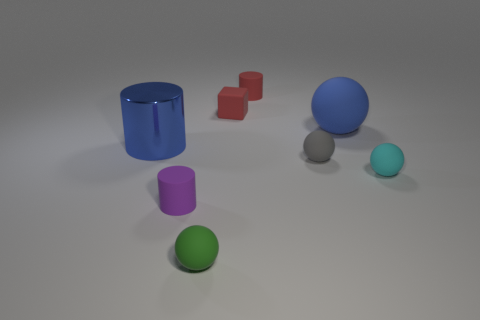What shape is the rubber thing that is both behind the small cyan ball and in front of the blue cylinder?
Ensure brevity in your answer.  Sphere. How many objects are purple cylinders or small cylinders on the left side of the small green object?
Your answer should be very brief. 1. Are the green thing and the tiny red cylinder made of the same material?
Give a very brief answer. Yes. What number of other things are there of the same shape as the cyan matte thing?
Keep it short and to the point. 3. What size is the rubber thing that is behind the large blue cylinder and in front of the rubber cube?
Provide a succinct answer. Large. How many shiny objects are either blue blocks or big blue spheres?
Your response must be concise. 0. There is a small object that is right of the gray thing; is its shape the same as the tiny rubber object that is in front of the small purple object?
Provide a short and direct response. Yes. Is there a red cube made of the same material as the cyan object?
Provide a short and direct response. Yes. What is the color of the tiny block?
Give a very brief answer. Red. There is a rubber cylinder on the left side of the green sphere; how big is it?
Offer a terse response. Small. 